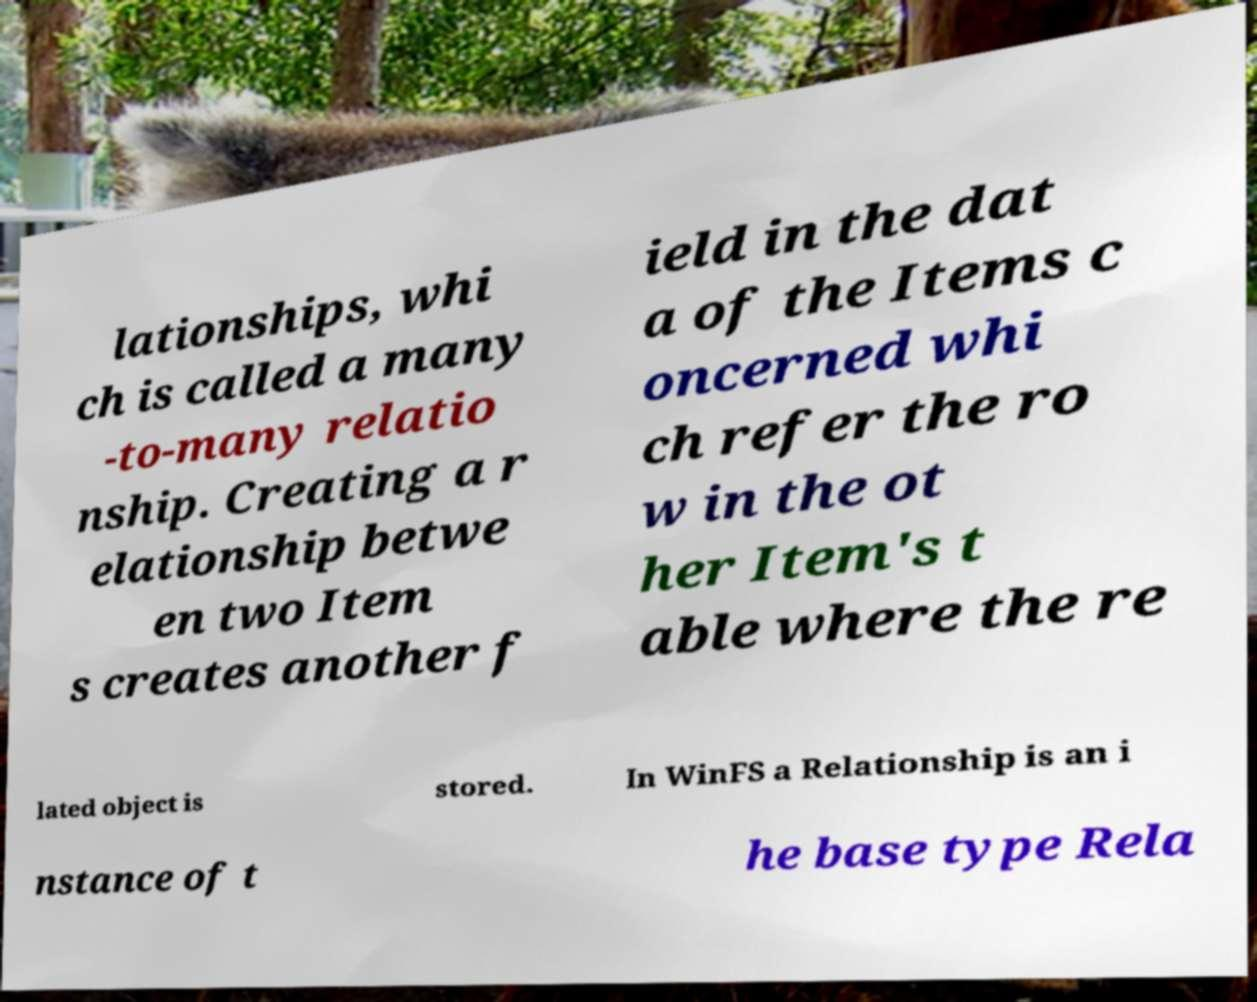There's text embedded in this image that I need extracted. Can you transcribe it verbatim? lationships, whi ch is called a many -to-many relatio nship. Creating a r elationship betwe en two Item s creates another f ield in the dat a of the Items c oncerned whi ch refer the ro w in the ot her Item's t able where the re lated object is stored. In WinFS a Relationship is an i nstance of t he base type Rela 